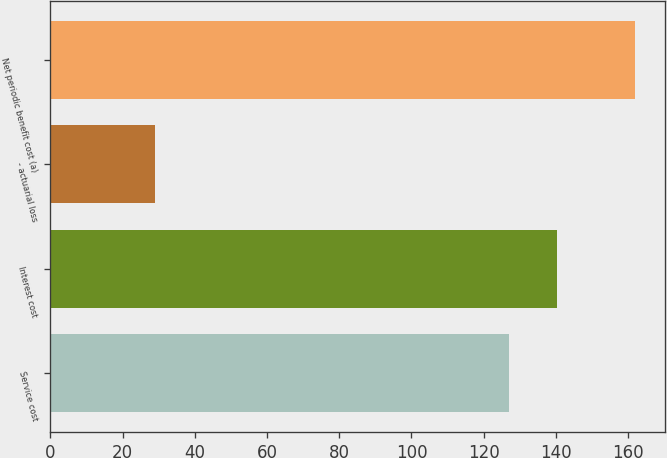<chart> <loc_0><loc_0><loc_500><loc_500><bar_chart><fcel>Service cost<fcel>Interest cost<fcel>- actuarial loss<fcel>Net periodic benefit cost (a)<nl><fcel>127<fcel>140.3<fcel>29<fcel>162<nl></chart> 